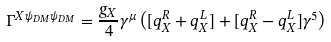<formula> <loc_0><loc_0><loc_500><loc_500>\Gamma ^ { X \psi _ { D M } \psi _ { D M } } = \frac { g _ { X } } { 4 } \gamma ^ { \mu } \left ( [ q _ { X } ^ { R } + q _ { X } ^ { L } ] + [ q _ { X } ^ { R } - q _ { X } ^ { L } ] \gamma ^ { 5 } \right )</formula> 